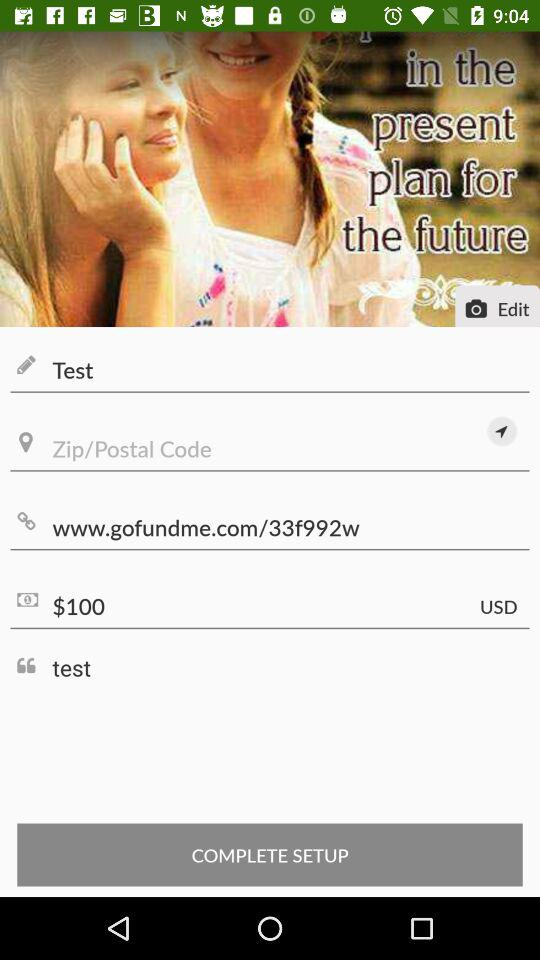What is the currency of the amount? The currency of the amount is USD. 